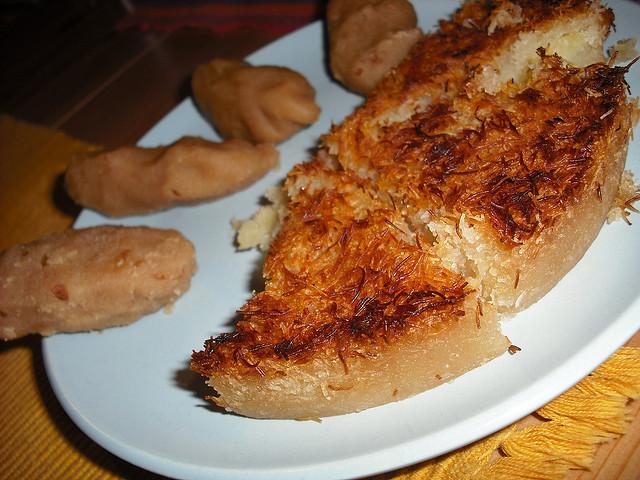What's under the plate?
Keep it brief. Table. What color is the plate?
Quick response, please. White. Is the food burnt?
Quick response, please. No. What kind of food is shown?
Write a very short answer. Pizza. 